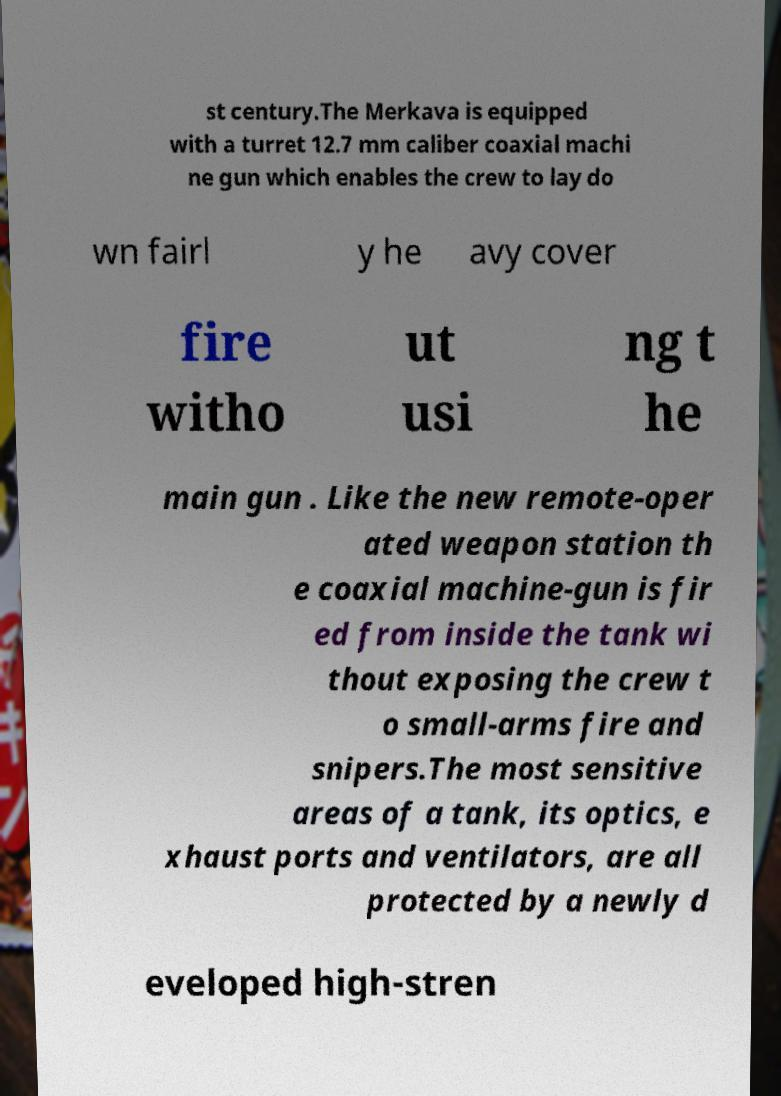There's text embedded in this image that I need extracted. Can you transcribe it verbatim? st century.The Merkava is equipped with a turret 12.7 mm caliber coaxial machi ne gun which enables the crew to lay do wn fairl y he avy cover fire witho ut usi ng t he main gun . Like the new remote-oper ated weapon station th e coaxial machine-gun is fir ed from inside the tank wi thout exposing the crew t o small-arms fire and snipers.The most sensitive areas of a tank, its optics, e xhaust ports and ventilators, are all protected by a newly d eveloped high-stren 